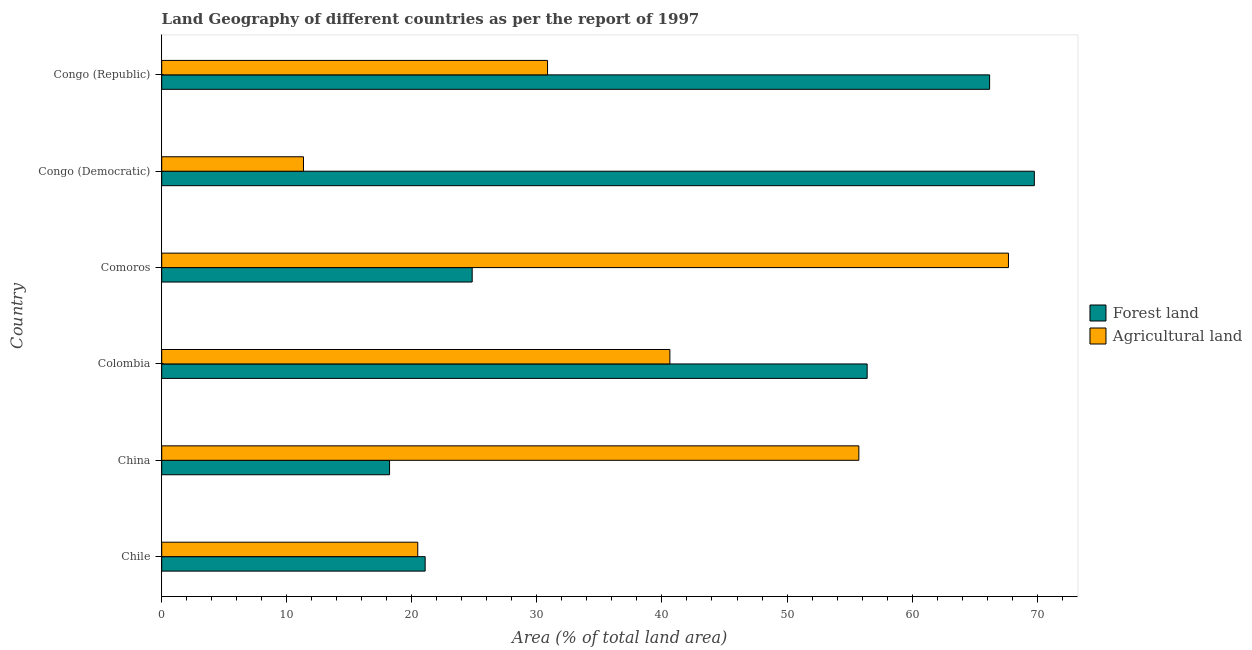How many groups of bars are there?
Offer a terse response. 6. Are the number of bars per tick equal to the number of legend labels?
Offer a very short reply. Yes. What is the label of the 2nd group of bars from the top?
Make the answer very short. Congo (Democratic). What is the percentage of land area under agriculture in Congo (Republic)?
Your response must be concise. 30.85. Across all countries, what is the maximum percentage of land area under agriculture?
Keep it short and to the point. 67.71. Across all countries, what is the minimum percentage of land area under agriculture?
Ensure brevity in your answer.  11.34. In which country was the percentage of land area under forests maximum?
Your response must be concise. Congo (Democratic). In which country was the percentage of land area under agriculture minimum?
Your answer should be very brief. Congo (Democratic). What is the total percentage of land area under forests in the graph?
Keep it short and to the point. 256.49. What is the difference between the percentage of land area under agriculture in China and that in Comoros?
Offer a terse response. -11.96. What is the difference between the percentage of land area under agriculture in Colombia and the percentage of land area under forests in Chile?
Ensure brevity in your answer.  19.57. What is the average percentage of land area under agriculture per country?
Make the answer very short. 37.79. What is the difference between the percentage of land area under agriculture and percentage of land area under forests in Congo (Republic)?
Your answer should be compact. -35.35. What is the ratio of the percentage of land area under agriculture in Chile to that in Congo (Democratic)?
Give a very brief answer. 1.81. What is the difference between the highest and the second highest percentage of land area under forests?
Offer a terse response. 3.58. What is the difference between the highest and the lowest percentage of land area under forests?
Offer a very short reply. 51.56. What does the 1st bar from the top in Congo (Democratic) represents?
Provide a succinct answer. Agricultural land. What does the 1st bar from the bottom in Congo (Democratic) represents?
Offer a very short reply. Forest land. How many bars are there?
Make the answer very short. 12. How many countries are there in the graph?
Give a very brief answer. 6. Does the graph contain any zero values?
Offer a terse response. No. Where does the legend appear in the graph?
Ensure brevity in your answer.  Center right. How many legend labels are there?
Your answer should be very brief. 2. What is the title of the graph?
Make the answer very short. Land Geography of different countries as per the report of 1997. What is the label or title of the X-axis?
Your answer should be compact. Area (% of total land area). What is the label or title of the Y-axis?
Your answer should be very brief. Country. What is the Area (% of total land area) of Forest land in Chile?
Your answer should be very brief. 21.07. What is the Area (% of total land area) of Agricultural land in Chile?
Provide a short and direct response. 20.47. What is the Area (% of total land area) in Forest land in China?
Keep it short and to the point. 18.22. What is the Area (% of total land area) of Agricultural land in China?
Ensure brevity in your answer.  55.74. What is the Area (% of total land area) of Forest land in Colombia?
Ensure brevity in your answer.  56.41. What is the Area (% of total land area) in Agricultural land in Colombia?
Make the answer very short. 40.63. What is the Area (% of total land area) of Forest land in Comoros?
Give a very brief answer. 24.83. What is the Area (% of total land area) in Agricultural land in Comoros?
Make the answer very short. 67.71. What is the Area (% of total land area) in Forest land in Congo (Democratic)?
Your response must be concise. 69.77. What is the Area (% of total land area) of Agricultural land in Congo (Democratic)?
Provide a succinct answer. 11.34. What is the Area (% of total land area) in Forest land in Congo (Republic)?
Keep it short and to the point. 66.2. What is the Area (% of total land area) in Agricultural land in Congo (Republic)?
Provide a short and direct response. 30.85. Across all countries, what is the maximum Area (% of total land area) of Forest land?
Provide a succinct answer. 69.77. Across all countries, what is the maximum Area (% of total land area) of Agricultural land?
Your answer should be very brief. 67.71. Across all countries, what is the minimum Area (% of total land area) of Forest land?
Ensure brevity in your answer.  18.22. Across all countries, what is the minimum Area (% of total land area) of Agricultural land?
Provide a short and direct response. 11.34. What is the total Area (% of total land area) in Forest land in the graph?
Provide a succinct answer. 256.49. What is the total Area (% of total land area) of Agricultural land in the graph?
Offer a very short reply. 226.74. What is the difference between the Area (% of total land area) of Forest land in Chile and that in China?
Make the answer very short. 2.85. What is the difference between the Area (% of total land area) of Agricultural land in Chile and that in China?
Your answer should be very brief. -35.27. What is the difference between the Area (% of total land area) of Forest land in Chile and that in Colombia?
Your answer should be compact. -35.34. What is the difference between the Area (% of total land area) of Agricultural land in Chile and that in Colombia?
Your answer should be compact. -20.16. What is the difference between the Area (% of total land area) of Forest land in Chile and that in Comoros?
Ensure brevity in your answer.  -3.76. What is the difference between the Area (% of total land area) in Agricultural land in Chile and that in Comoros?
Give a very brief answer. -47.23. What is the difference between the Area (% of total land area) of Forest land in Chile and that in Congo (Democratic)?
Ensure brevity in your answer.  -48.71. What is the difference between the Area (% of total land area) of Agricultural land in Chile and that in Congo (Democratic)?
Your answer should be very brief. 9.14. What is the difference between the Area (% of total land area) of Forest land in Chile and that in Congo (Republic)?
Provide a short and direct response. -45.13. What is the difference between the Area (% of total land area) of Agricultural land in Chile and that in Congo (Republic)?
Offer a very short reply. -10.38. What is the difference between the Area (% of total land area) in Forest land in China and that in Colombia?
Provide a short and direct response. -38.19. What is the difference between the Area (% of total land area) of Agricultural land in China and that in Colombia?
Make the answer very short. 15.11. What is the difference between the Area (% of total land area) in Forest land in China and that in Comoros?
Your answer should be very brief. -6.61. What is the difference between the Area (% of total land area) of Agricultural land in China and that in Comoros?
Ensure brevity in your answer.  -11.96. What is the difference between the Area (% of total land area) of Forest land in China and that in Congo (Democratic)?
Your answer should be very brief. -51.56. What is the difference between the Area (% of total land area) in Agricultural land in China and that in Congo (Democratic)?
Ensure brevity in your answer.  44.41. What is the difference between the Area (% of total land area) of Forest land in China and that in Congo (Republic)?
Your answer should be very brief. -47.98. What is the difference between the Area (% of total land area) in Agricultural land in China and that in Congo (Republic)?
Provide a short and direct response. 24.89. What is the difference between the Area (% of total land area) of Forest land in Colombia and that in Comoros?
Offer a very short reply. 31.58. What is the difference between the Area (% of total land area) in Agricultural land in Colombia and that in Comoros?
Offer a very short reply. -27.07. What is the difference between the Area (% of total land area) of Forest land in Colombia and that in Congo (Democratic)?
Keep it short and to the point. -13.37. What is the difference between the Area (% of total land area) of Agricultural land in Colombia and that in Congo (Democratic)?
Your answer should be compact. 29.3. What is the difference between the Area (% of total land area) in Forest land in Colombia and that in Congo (Republic)?
Provide a short and direct response. -9.79. What is the difference between the Area (% of total land area) of Agricultural land in Colombia and that in Congo (Republic)?
Ensure brevity in your answer.  9.78. What is the difference between the Area (% of total land area) in Forest land in Comoros and that in Congo (Democratic)?
Provide a succinct answer. -44.95. What is the difference between the Area (% of total land area) of Agricultural land in Comoros and that in Congo (Democratic)?
Give a very brief answer. 56.37. What is the difference between the Area (% of total land area) in Forest land in Comoros and that in Congo (Republic)?
Ensure brevity in your answer.  -41.37. What is the difference between the Area (% of total land area) of Agricultural land in Comoros and that in Congo (Republic)?
Keep it short and to the point. 36.85. What is the difference between the Area (% of total land area) in Forest land in Congo (Democratic) and that in Congo (Republic)?
Provide a succinct answer. 3.58. What is the difference between the Area (% of total land area) in Agricultural land in Congo (Democratic) and that in Congo (Republic)?
Offer a terse response. -19.52. What is the difference between the Area (% of total land area) of Forest land in Chile and the Area (% of total land area) of Agricultural land in China?
Offer a very short reply. -34.68. What is the difference between the Area (% of total land area) in Forest land in Chile and the Area (% of total land area) in Agricultural land in Colombia?
Ensure brevity in your answer.  -19.57. What is the difference between the Area (% of total land area) of Forest land in Chile and the Area (% of total land area) of Agricultural land in Comoros?
Give a very brief answer. -46.64. What is the difference between the Area (% of total land area) in Forest land in Chile and the Area (% of total land area) in Agricultural land in Congo (Democratic)?
Your answer should be very brief. 9.73. What is the difference between the Area (% of total land area) in Forest land in Chile and the Area (% of total land area) in Agricultural land in Congo (Republic)?
Offer a very short reply. -9.79. What is the difference between the Area (% of total land area) of Forest land in China and the Area (% of total land area) of Agricultural land in Colombia?
Give a very brief answer. -22.41. What is the difference between the Area (% of total land area) in Forest land in China and the Area (% of total land area) in Agricultural land in Comoros?
Keep it short and to the point. -49.49. What is the difference between the Area (% of total land area) of Forest land in China and the Area (% of total land area) of Agricultural land in Congo (Democratic)?
Your response must be concise. 6.88. What is the difference between the Area (% of total land area) in Forest land in China and the Area (% of total land area) in Agricultural land in Congo (Republic)?
Your answer should be very brief. -12.63. What is the difference between the Area (% of total land area) in Forest land in Colombia and the Area (% of total land area) in Agricultural land in Comoros?
Your answer should be very brief. -11.3. What is the difference between the Area (% of total land area) of Forest land in Colombia and the Area (% of total land area) of Agricultural land in Congo (Democratic)?
Provide a short and direct response. 45.07. What is the difference between the Area (% of total land area) of Forest land in Colombia and the Area (% of total land area) of Agricultural land in Congo (Republic)?
Give a very brief answer. 25.56. What is the difference between the Area (% of total land area) in Forest land in Comoros and the Area (% of total land area) in Agricultural land in Congo (Democratic)?
Keep it short and to the point. 13.49. What is the difference between the Area (% of total land area) in Forest land in Comoros and the Area (% of total land area) in Agricultural land in Congo (Republic)?
Offer a very short reply. -6.03. What is the difference between the Area (% of total land area) in Forest land in Congo (Democratic) and the Area (% of total land area) in Agricultural land in Congo (Republic)?
Offer a terse response. 38.92. What is the average Area (% of total land area) of Forest land per country?
Make the answer very short. 42.75. What is the average Area (% of total land area) in Agricultural land per country?
Your response must be concise. 37.79. What is the difference between the Area (% of total land area) of Forest land and Area (% of total land area) of Agricultural land in Chile?
Ensure brevity in your answer.  0.59. What is the difference between the Area (% of total land area) in Forest land and Area (% of total land area) in Agricultural land in China?
Ensure brevity in your answer.  -37.52. What is the difference between the Area (% of total land area) of Forest land and Area (% of total land area) of Agricultural land in Colombia?
Offer a terse response. 15.77. What is the difference between the Area (% of total land area) of Forest land and Area (% of total land area) of Agricultural land in Comoros?
Ensure brevity in your answer.  -42.88. What is the difference between the Area (% of total land area) of Forest land and Area (% of total land area) of Agricultural land in Congo (Democratic)?
Provide a short and direct response. 58.44. What is the difference between the Area (% of total land area) in Forest land and Area (% of total land area) in Agricultural land in Congo (Republic)?
Provide a succinct answer. 35.35. What is the ratio of the Area (% of total land area) in Forest land in Chile to that in China?
Give a very brief answer. 1.16. What is the ratio of the Area (% of total land area) in Agricultural land in Chile to that in China?
Give a very brief answer. 0.37. What is the ratio of the Area (% of total land area) in Forest land in Chile to that in Colombia?
Offer a very short reply. 0.37. What is the ratio of the Area (% of total land area) in Agricultural land in Chile to that in Colombia?
Offer a terse response. 0.5. What is the ratio of the Area (% of total land area) in Forest land in Chile to that in Comoros?
Keep it short and to the point. 0.85. What is the ratio of the Area (% of total land area) in Agricultural land in Chile to that in Comoros?
Provide a short and direct response. 0.3. What is the ratio of the Area (% of total land area) in Forest land in Chile to that in Congo (Democratic)?
Give a very brief answer. 0.3. What is the ratio of the Area (% of total land area) in Agricultural land in Chile to that in Congo (Democratic)?
Make the answer very short. 1.81. What is the ratio of the Area (% of total land area) in Forest land in Chile to that in Congo (Republic)?
Keep it short and to the point. 0.32. What is the ratio of the Area (% of total land area) of Agricultural land in Chile to that in Congo (Republic)?
Ensure brevity in your answer.  0.66. What is the ratio of the Area (% of total land area) in Forest land in China to that in Colombia?
Offer a terse response. 0.32. What is the ratio of the Area (% of total land area) of Agricultural land in China to that in Colombia?
Give a very brief answer. 1.37. What is the ratio of the Area (% of total land area) in Forest land in China to that in Comoros?
Your answer should be compact. 0.73. What is the ratio of the Area (% of total land area) in Agricultural land in China to that in Comoros?
Keep it short and to the point. 0.82. What is the ratio of the Area (% of total land area) of Forest land in China to that in Congo (Democratic)?
Keep it short and to the point. 0.26. What is the ratio of the Area (% of total land area) of Agricultural land in China to that in Congo (Democratic)?
Your answer should be very brief. 4.92. What is the ratio of the Area (% of total land area) in Forest land in China to that in Congo (Republic)?
Your answer should be very brief. 0.28. What is the ratio of the Area (% of total land area) of Agricultural land in China to that in Congo (Republic)?
Provide a short and direct response. 1.81. What is the ratio of the Area (% of total land area) of Forest land in Colombia to that in Comoros?
Offer a very short reply. 2.27. What is the ratio of the Area (% of total land area) in Agricultural land in Colombia to that in Comoros?
Offer a terse response. 0.6. What is the ratio of the Area (% of total land area) of Forest land in Colombia to that in Congo (Democratic)?
Ensure brevity in your answer.  0.81. What is the ratio of the Area (% of total land area) in Agricultural land in Colombia to that in Congo (Democratic)?
Your answer should be very brief. 3.58. What is the ratio of the Area (% of total land area) in Forest land in Colombia to that in Congo (Republic)?
Your answer should be very brief. 0.85. What is the ratio of the Area (% of total land area) in Agricultural land in Colombia to that in Congo (Republic)?
Provide a short and direct response. 1.32. What is the ratio of the Area (% of total land area) in Forest land in Comoros to that in Congo (Democratic)?
Provide a succinct answer. 0.36. What is the ratio of the Area (% of total land area) of Agricultural land in Comoros to that in Congo (Democratic)?
Ensure brevity in your answer.  5.97. What is the ratio of the Area (% of total land area) of Agricultural land in Comoros to that in Congo (Republic)?
Offer a very short reply. 2.19. What is the ratio of the Area (% of total land area) in Forest land in Congo (Democratic) to that in Congo (Republic)?
Provide a short and direct response. 1.05. What is the ratio of the Area (% of total land area) of Agricultural land in Congo (Democratic) to that in Congo (Republic)?
Offer a very short reply. 0.37. What is the difference between the highest and the second highest Area (% of total land area) in Forest land?
Give a very brief answer. 3.58. What is the difference between the highest and the second highest Area (% of total land area) of Agricultural land?
Your response must be concise. 11.96. What is the difference between the highest and the lowest Area (% of total land area) in Forest land?
Your response must be concise. 51.56. What is the difference between the highest and the lowest Area (% of total land area) in Agricultural land?
Offer a terse response. 56.37. 